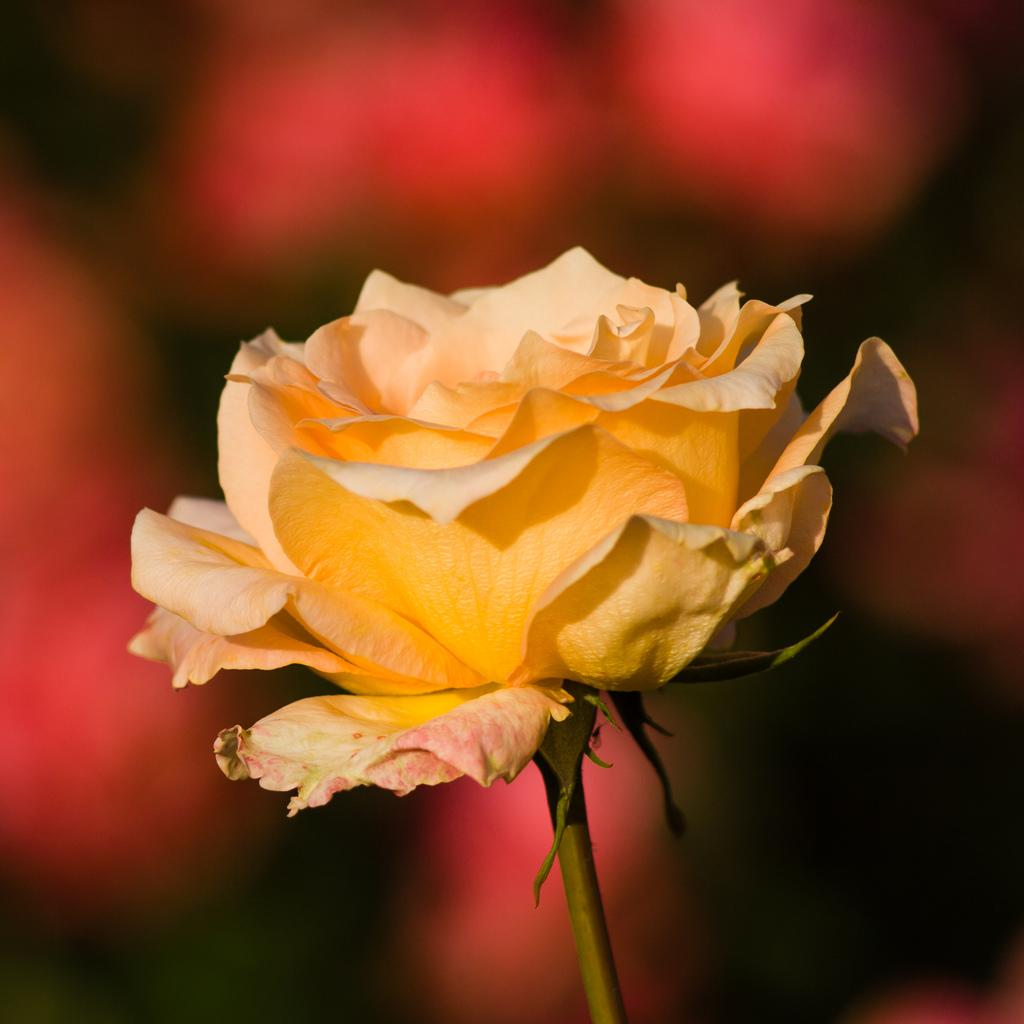What is the main subject in the foreground of the picture? There is a yellow rose in the foreground of the picture. What can be observed about the background of the image? The background of the image is blurred. What type of cactus can be seen in the background of the image? There is no cactus present in the image; the background is blurred. Can you tell me how many church bells are ringing in the image? There is no church or church bells present in the image; it features a yellow rose in the foreground and a blurred background. 